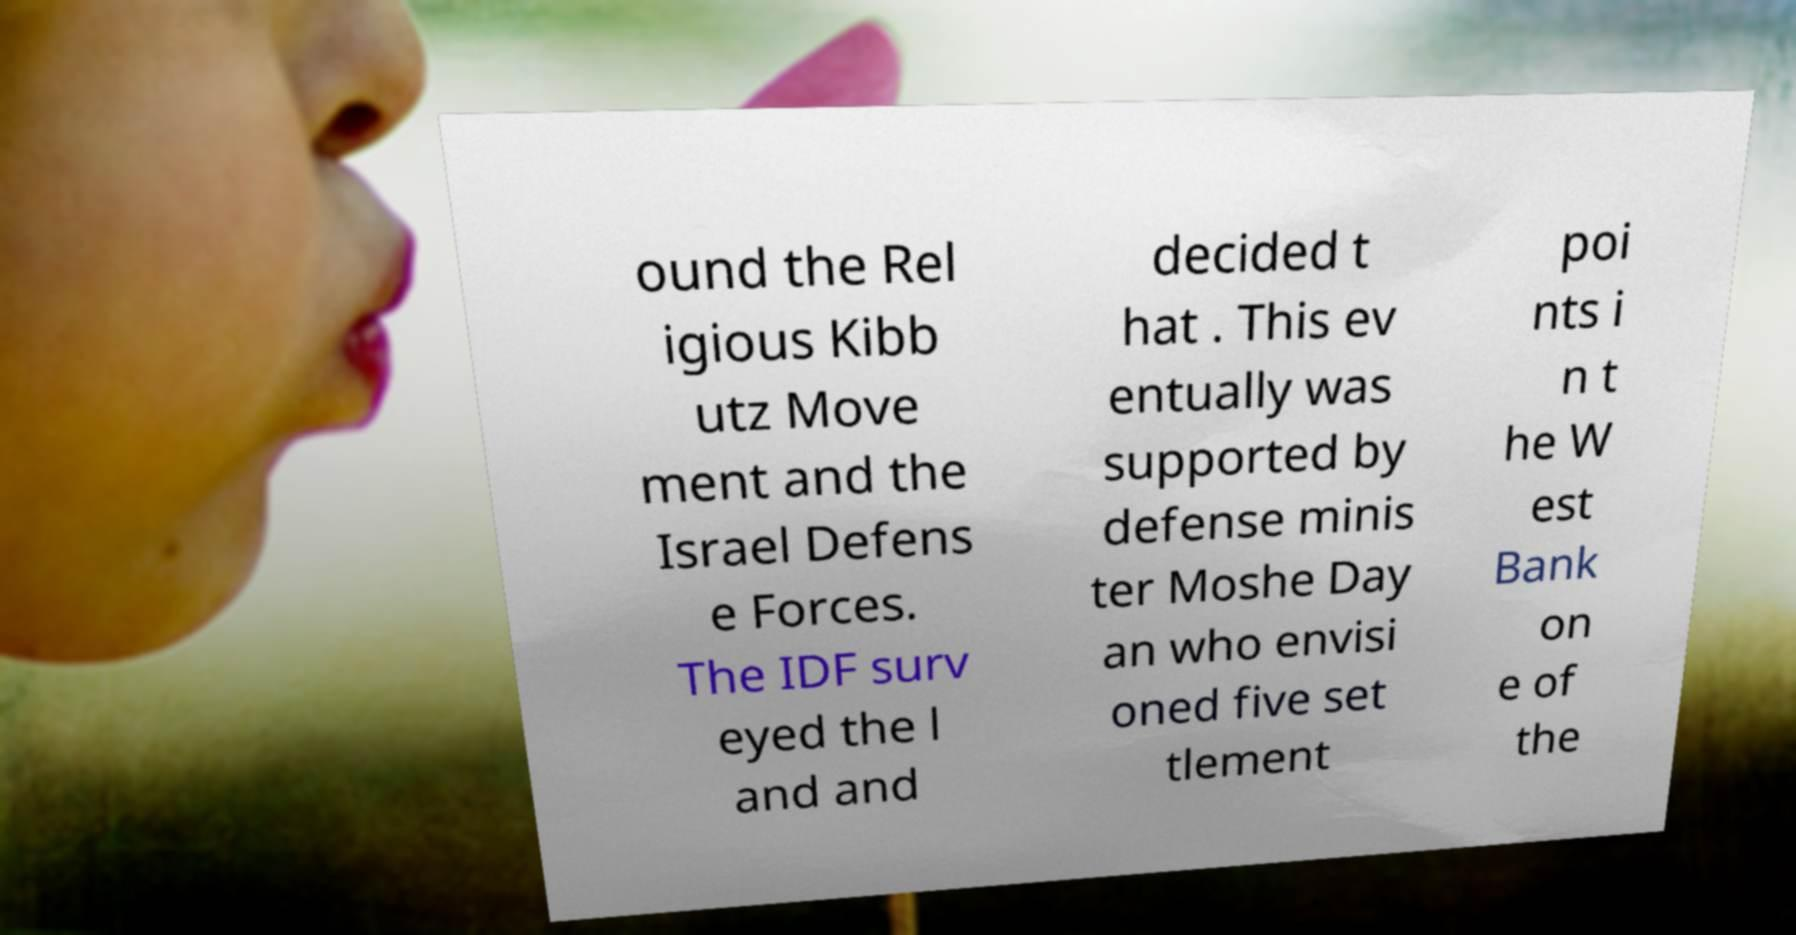Can you accurately transcribe the text from the provided image for me? ound the Rel igious Kibb utz Move ment and the Israel Defens e Forces. The IDF surv eyed the l and and decided t hat . This ev entually was supported by defense minis ter Moshe Day an who envisi oned five set tlement poi nts i n t he W est Bank on e of the 